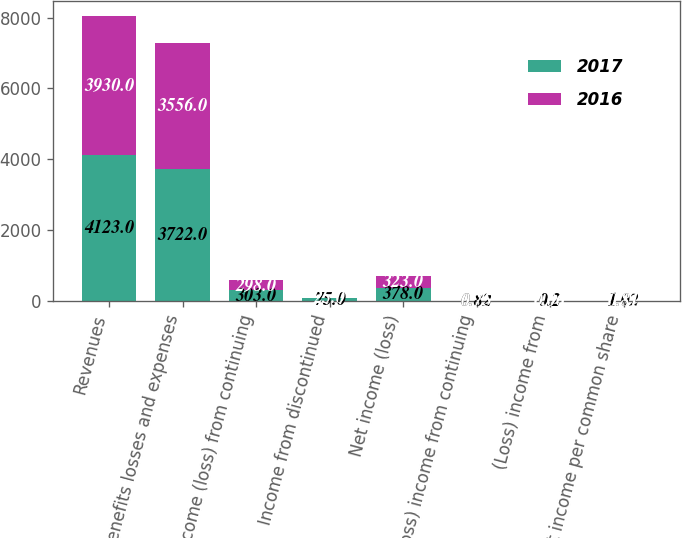Convert chart to OTSL. <chart><loc_0><loc_0><loc_500><loc_500><stacked_bar_chart><ecel><fcel>Revenues<fcel>Benefits losses and expenses<fcel>Income (loss) from continuing<fcel>Income from discontinued<fcel>Net income (loss)<fcel>(Loss) income from continuing<fcel>(Loss) income from<fcel>Net income per common share<nl><fcel>2017<fcel>4123<fcel>3722<fcel>303<fcel>75<fcel>378<fcel>0.82<fcel>0.2<fcel>1.02<nl><fcel>2016<fcel>3930<fcel>3556<fcel>298<fcel>25<fcel>323<fcel>0.75<fcel>0.06<fcel>0.81<nl></chart> 